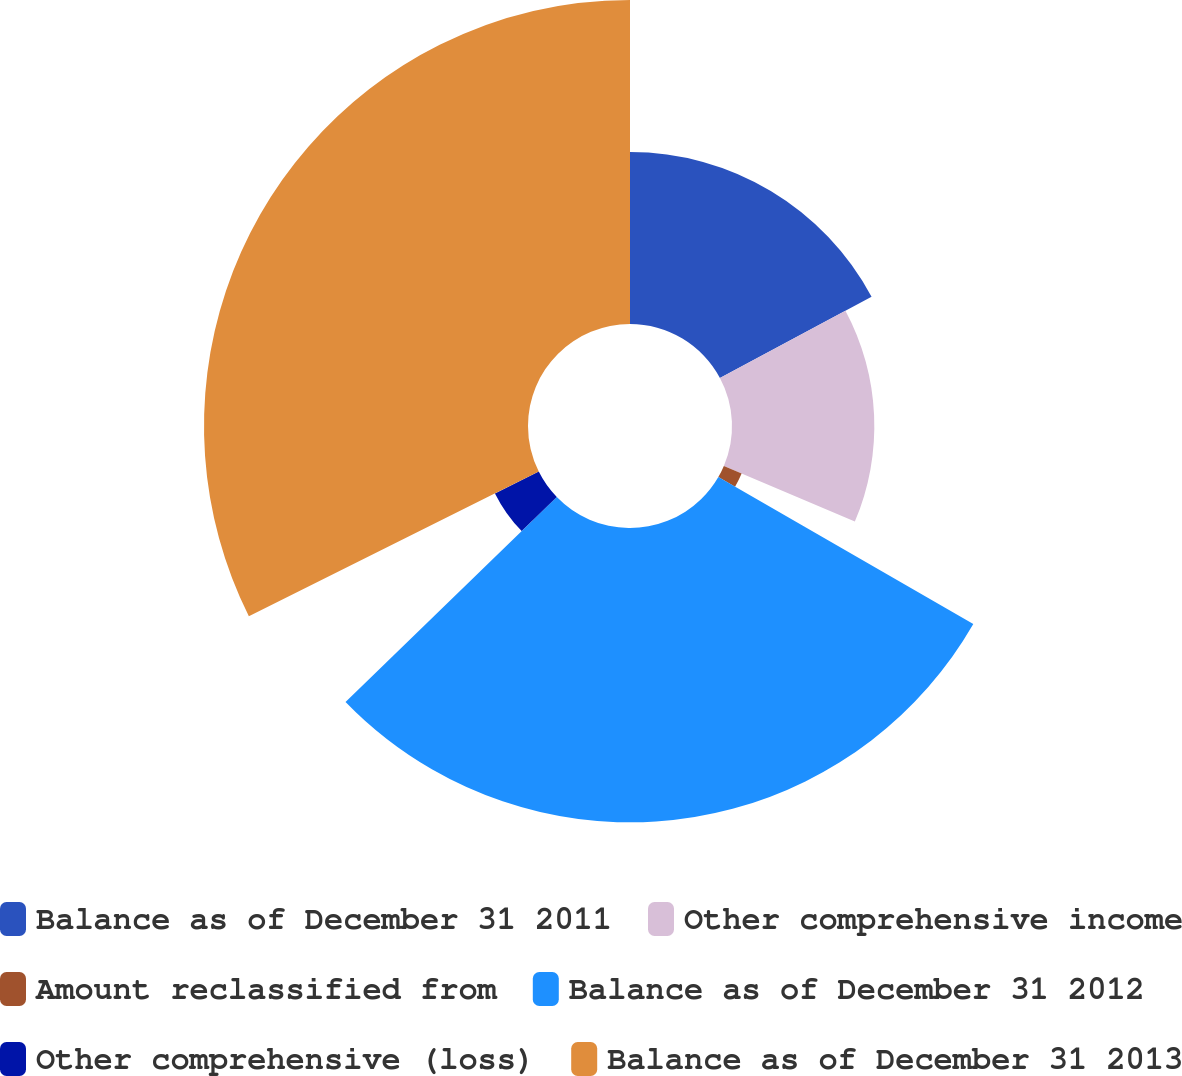<chart> <loc_0><loc_0><loc_500><loc_500><pie_chart><fcel>Balance as of December 31 2011<fcel>Other comprehensive income<fcel>Amount reclassified from<fcel>Balance as of December 31 2012<fcel>Other comprehensive (loss)<fcel>Balance as of December 31 2013<nl><fcel>17.18%<fcel>14.22%<fcel>1.93%<fcel>29.41%<fcel>4.89%<fcel>32.37%<nl></chart> 